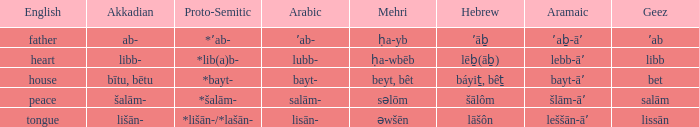Could you parse the entire table as a dict? {'header': ['English', 'Akkadian', 'Proto-Semitic', 'Arabic', 'Mehri', 'Hebrew', 'Aramaic', 'Geez'], 'rows': [['father', 'ab-', '*ʼab-', 'ʼab-', 'ḥa-yb', 'ʼāḇ', 'ʼaḇ-āʼ', 'ʼab'], ['heart', 'libb-', '*lib(a)b-', 'lubb-', 'ḥa-wbēb', 'lēḇ(āḇ)', 'lebb-āʼ', 'libb'], ['house', 'bītu, bētu', '*bayt-', 'bayt-', 'beyt, bêt', 'báyiṯ, bêṯ', 'bayt-āʼ', 'bet'], ['peace', 'šalām-', '*šalām-', 'salām-', 'səlōm', 'šālôm', 'šlām-āʼ', 'salām'], ['tongue', 'lišān-', '*lišān-/*lašān-', 'lisān-', 'əwšēn', 'lāšôn', 'leššān-āʼ', 'lissān']]} If in English it's house, what is it in proto-semitic? *bayt-. 